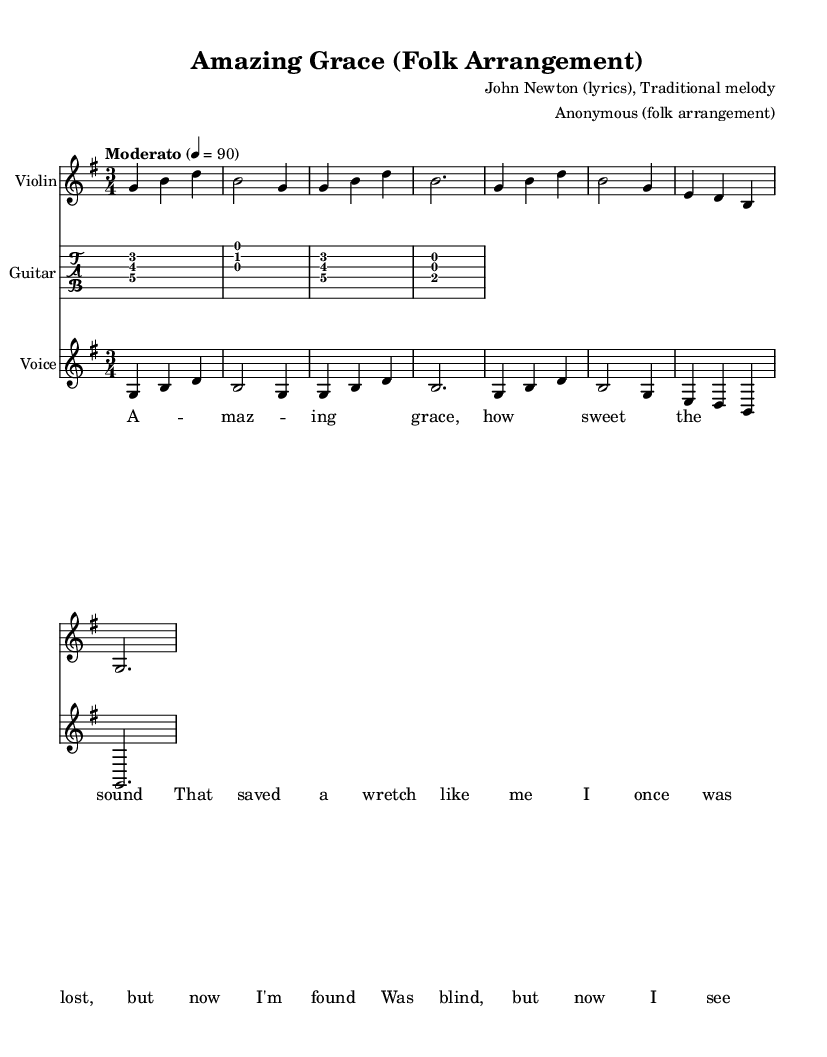What is the key signature of this music? The key signature is G major, which has one sharp (F#). This is determined by the placement of the sharp symbol in the key signature section of the sheet music.
Answer: G major What is the time signature of this music? The time signature is 3/4, indicated at the beginning of the score. This means there are three beats in each measure, and the quarter note gets one beat.
Answer: 3/4 What is the tempo marking for this arrangement? The tempo is marked as "Moderato," with a metronome indication of 90 beats per minute. This can be seen in the tempo directive placed at the start of the sheet music.
Answer: Moderato How many verses does the hymn contain in this score? The score presents one verse of lyrics. The lyrics are visible as a single block, indicating it is a complete stanza for performance.
Answer: One verse Which instruments are featured in this arrangement? The arrangement includes violin, guitar, and voice, as indicated by their respective staff labels in the score. These instruments are part of the ensemble created for the folk arrangement.
Answer: Violin, guitar, voice What is the lyric's first line of this hymn? The first line of the lyrics is "Amazing grace, how sweet the sound." This is directly stated in the lyric section of the score.
Answer: Amazing grace, how sweet the sound 